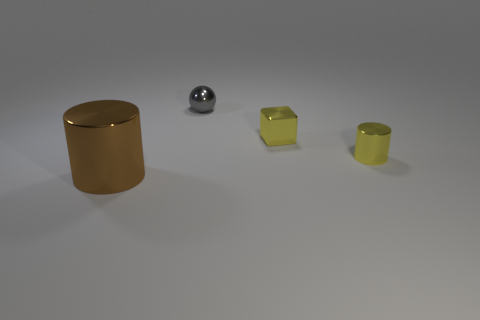There is a shiny cylinder that is in front of the yellow shiny thing that is in front of the yellow thing behind the yellow shiny cylinder; what size is it?
Ensure brevity in your answer.  Large. How many objects are either large metallic objects or small cylinders?
Provide a short and direct response. 2. The small thing that is both in front of the small gray sphere and to the left of the small yellow metal cylinder has what shape?
Your response must be concise. Cube. There is a big metal object; does it have the same shape as the tiny yellow shiny object in front of the cube?
Your answer should be compact. Yes. Are there any yellow objects right of the small block?
Provide a succinct answer. Yes. How many blocks are big objects or yellow things?
Your response must be concise. 1. What size is the cylinder that is on the right side of the large brown metal cylinder?
Offer a very short reply. Small. Is there a block of the same color as the small metallic cylinder?
Provide a short and direct response. Yes. Does the cylinder that is to the right of the gray thing have the same size as the tiny shiny sphere?
Provide a succinct answer. Yes. What color is the small cylinder?
Your answer should be very brief. Yellow. 